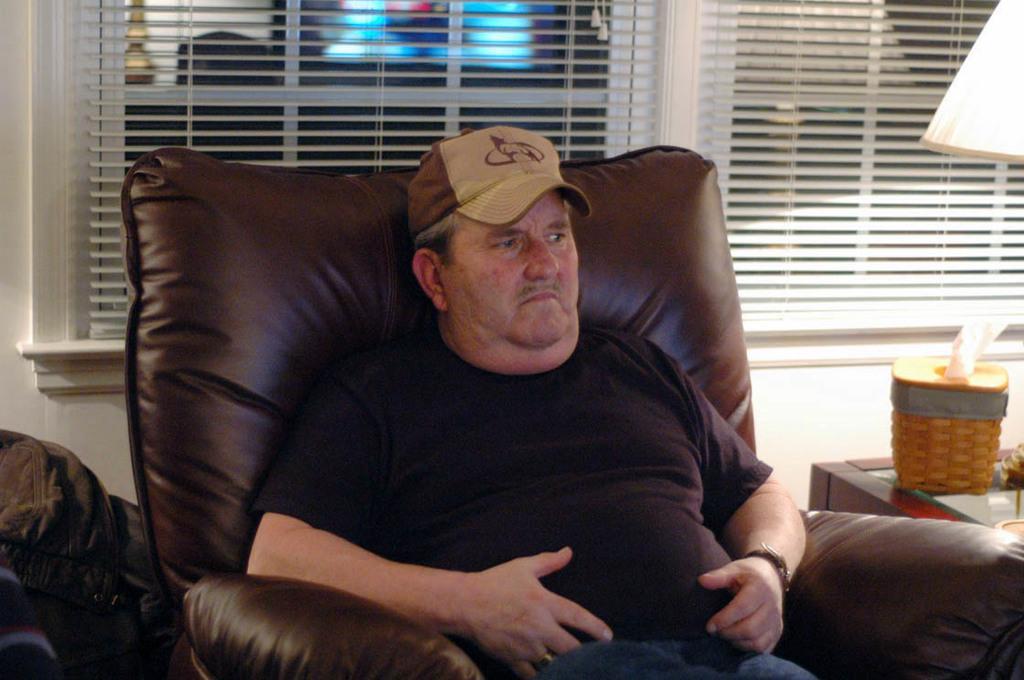Please provide a concise description of this image. The image is inside the room. In the image there is a man wearing a hat sitting on couch. on right side there is a table, on table we can see a lamp in background there is a window. 